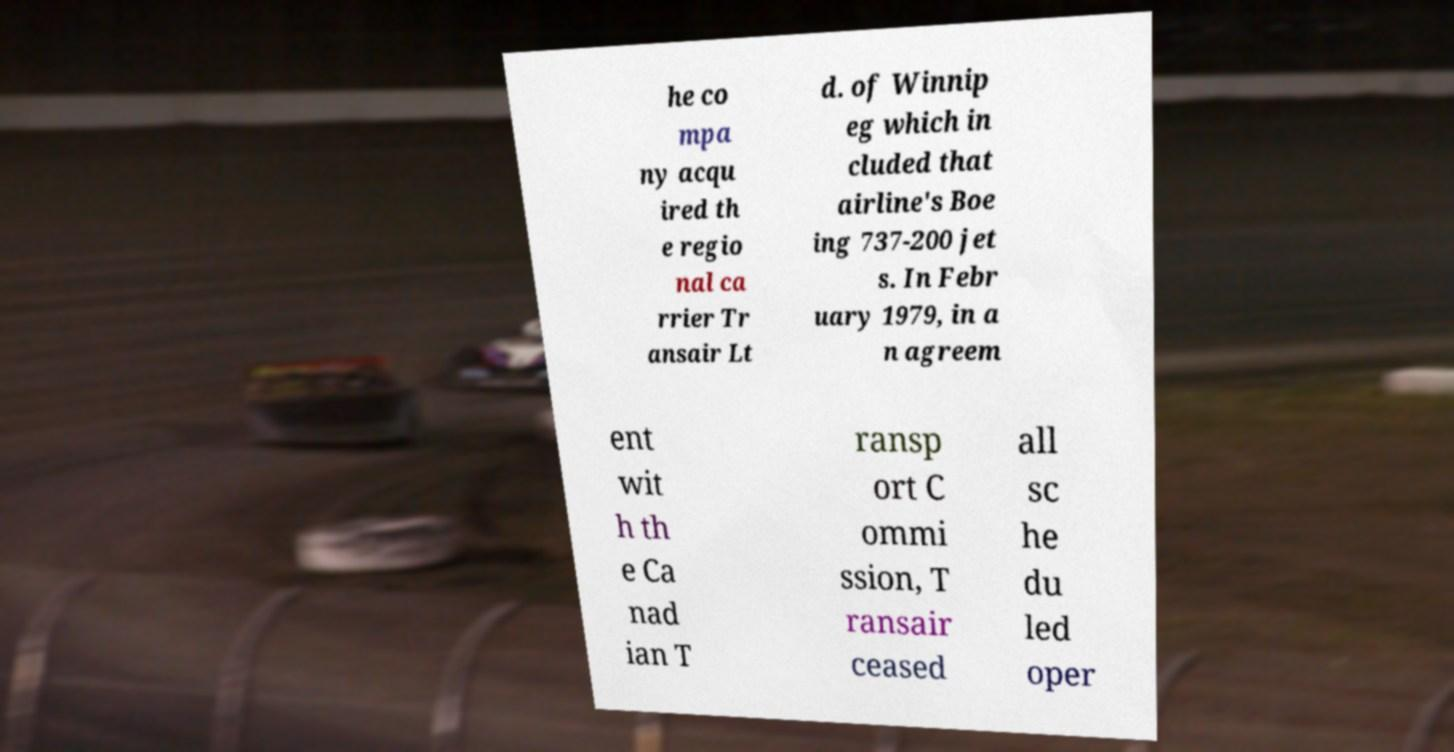Please identify and transcribe the text found in this image. he co mpa ny acqu ired th e regio nal ca rrier Tr ansair Lt d. of Winnip eg which in cluded that airline's Boe ing 737-200 jet s. In Febr uary 1979, in a n agreem ent wit h th e Ca nad ian T ransp ort C ommi ssion, T ransair ceased all sc he du led oper 